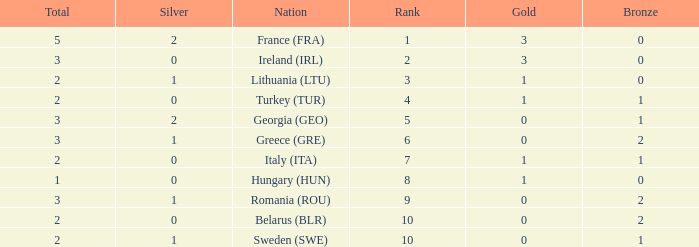What's the total of Sweden (SWE) having less than 1 silver? None. 